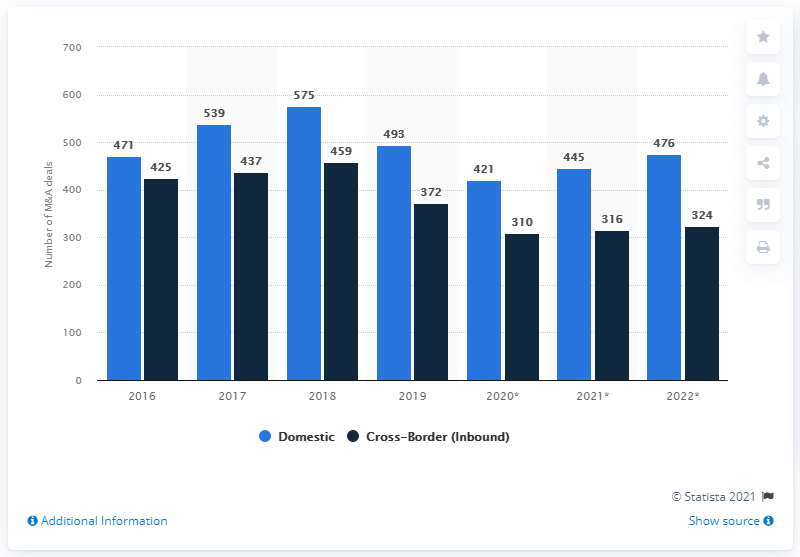Specify some key components in this picture. In 2019, there were 372 cross-border mergers and acquisitions transactions in Italy. In 2019, there were 493 domestic merger and acquisition transactions in Italy. 